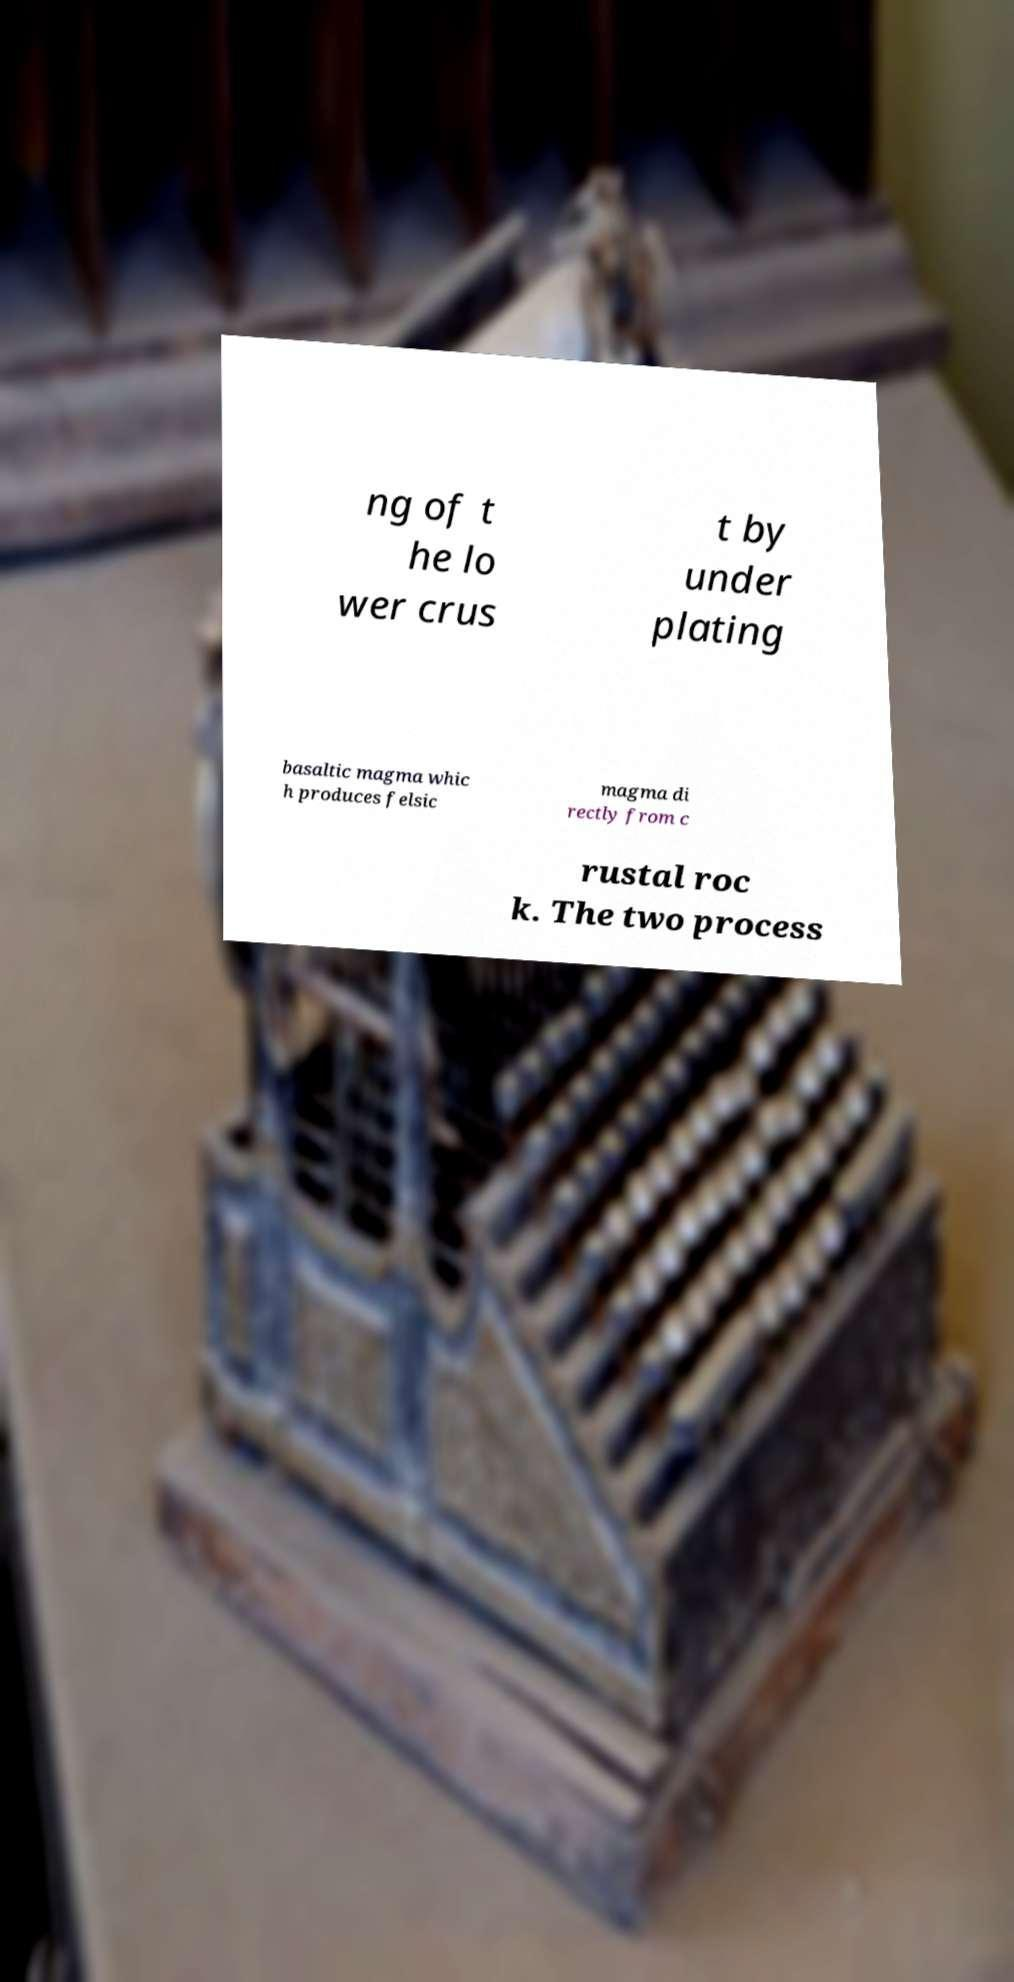Can you accurately transcribe the text from the provided image for me? ng of t he lo wer crus t by under plating basaltic magma whic h produces felsic magma di rectly from c rustal roc k. The two process 